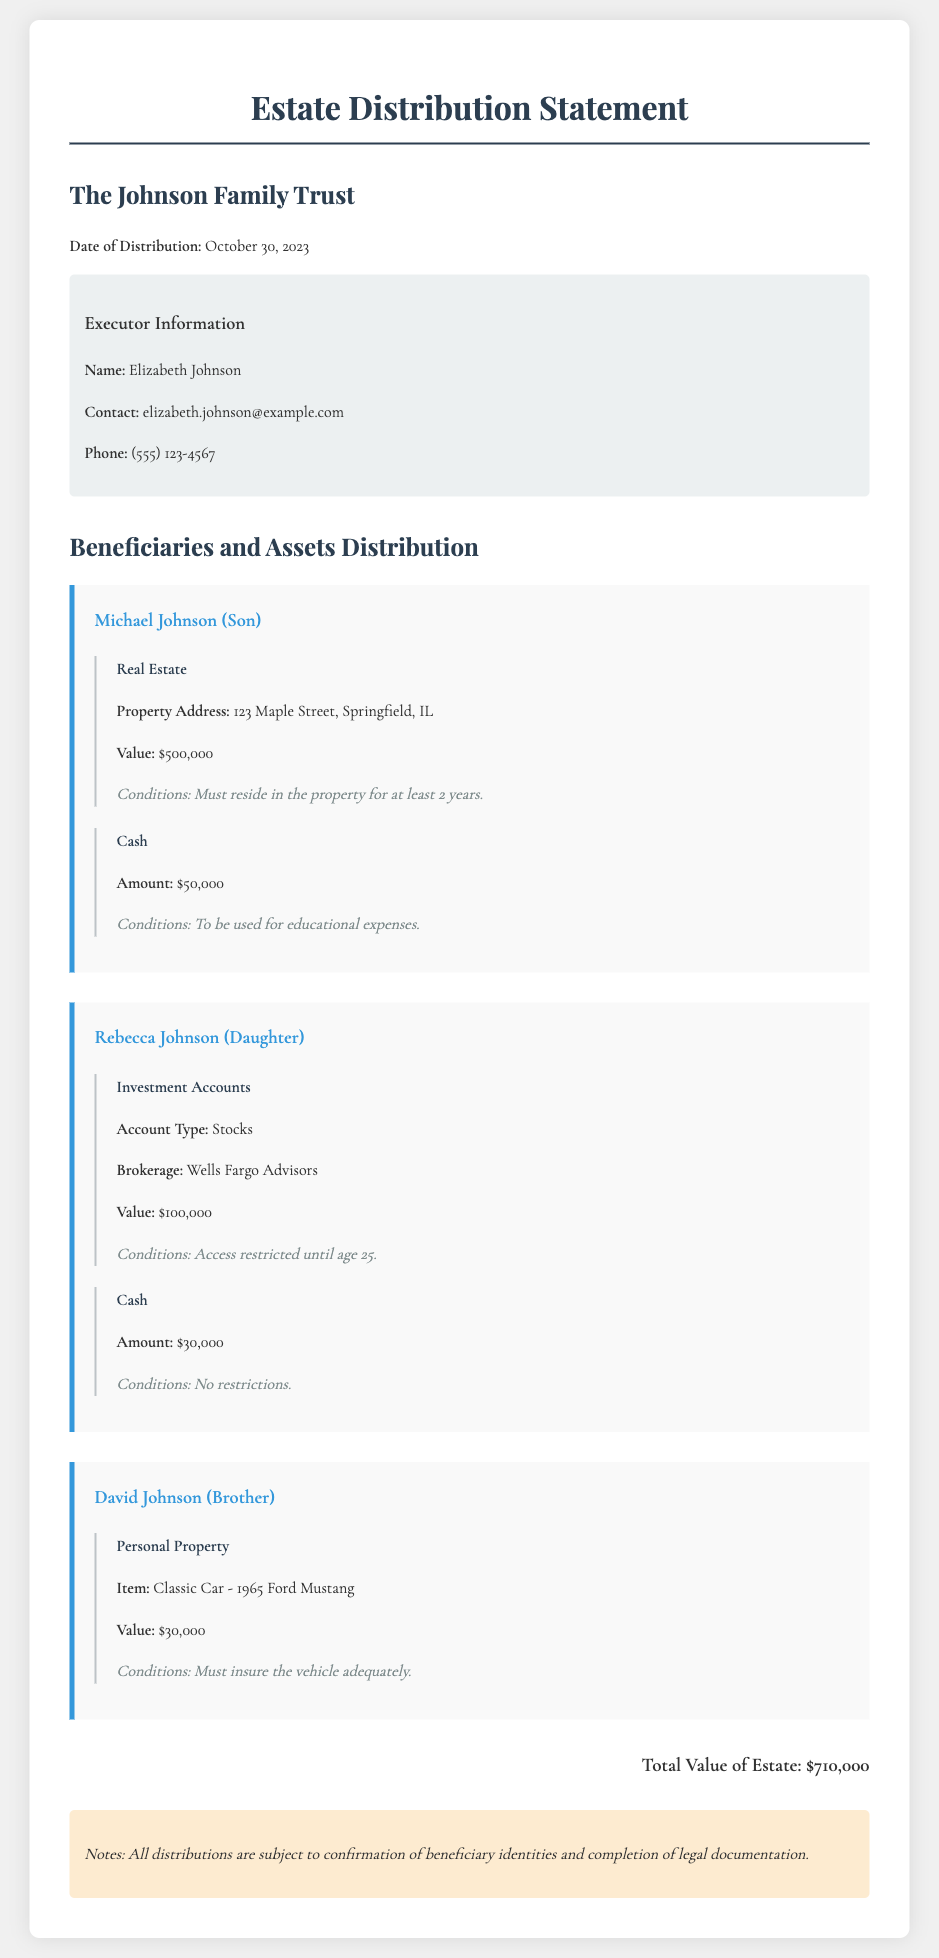What is the name of the executor? The executor is mentioned in the executor information section, and the name provided is Elizabeth Johnson.
Answer: Elizabeth Johnson What is the total value of the estate? The total value of the estate is listed at the bottom of the document and is stated as $710,000.
Answer: $710,000 How much cash will Michael Johnson receive? Michael Johnson's cash distribution is specified as $50,000 in the cash section of his beneficiary information.
Answer: $50,000 What condition is attached to Rebecca Johnson's investment accounts? The conditions for Rebecca Johnson's investment accounts specify that access is restricted until she turns 25 years old.
Answer: Access restricted until age 25 What type of property will David Johnson receive? The document mentions that David Johnson will receive personal property, specifically a classic car.
Answer: Classic Car - 1965 Ford Mustang What is the contact phone number for the executor? The contact phone number for the executor is provided in the executor information section as (555) 123-4567.
Answer: (555) 123-4567 What condition is attached to the cash distribution received by Rebecca Johnson? The document states that there are no restrictions on the cash distribution that Rebecca Johnson will receive.
Answer: No restrictions What is the value of the real estate that Michael Johnson will receive? The document specifies the value of the real estate given to Michael Johnson as $500,000.
Answer: $500,000 How much cash will Rebecca Johnson receive? It is stated in the document that Rebecca Johnson will receive $30,000 in cash distribution.
Answer: $30,000 